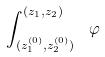<formula> <loc_0><loc_0><loc_500><loc_500>\int _ { ( z ^ { ( 0 ) } _ { 1 } , z ^ { ( 0 ) } _ { 2 } ) } ^ { ( z _ { 1 } , z _ { 2 } ) } \ \varphi</formula> 